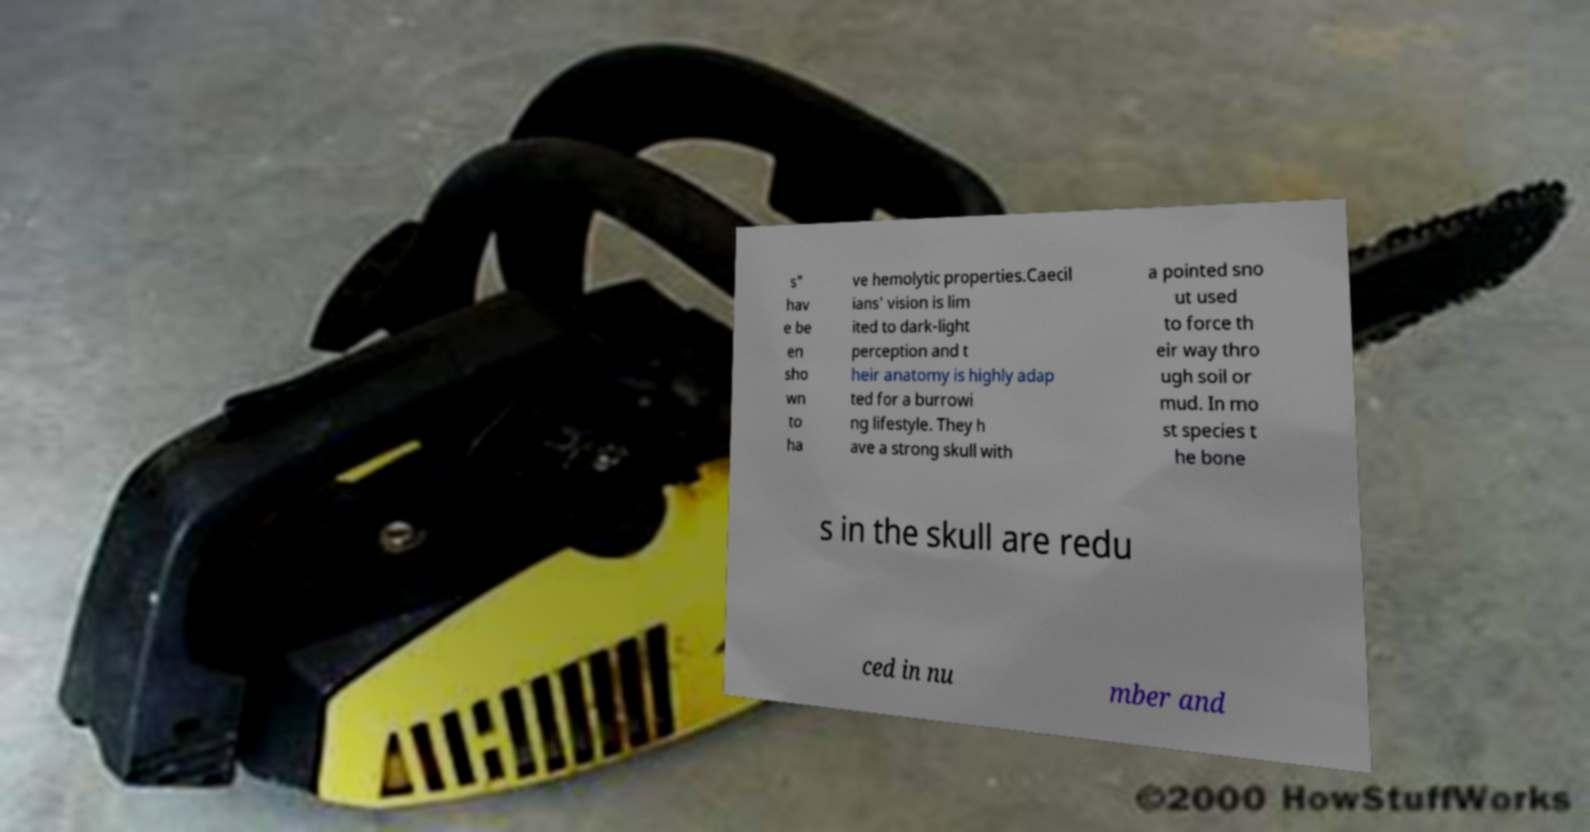Can you accurately transcribe the text from the provided image for me? s" hav e be en sho wn to ha ve hemolytic properties.Caecil ians' vision is lim ited to dark-light perception and t heir anatomy is highly adap ted for a burrowi ng lifestyle. They h ave a strong skull with a pointed sno ut used to force th eir way thro ugh soil or mud. In mo st species t he bone s in the skull are redu ced in nu mber and 